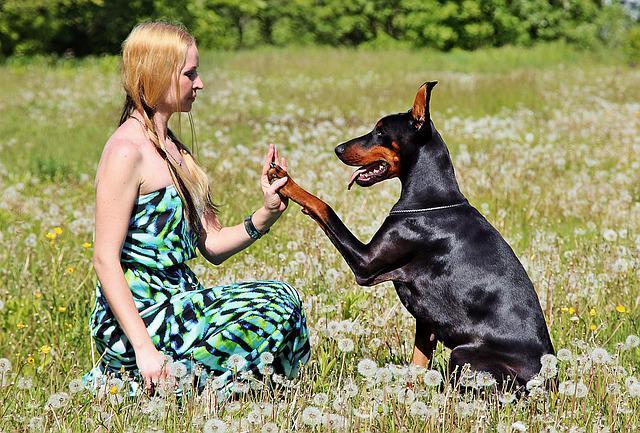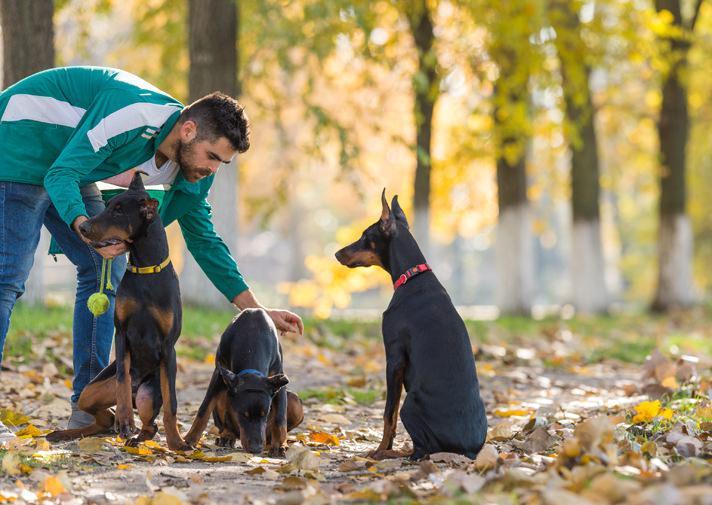The first image is the image on the left, the second image is the image on the right. Evaluate the accuracy of this statement regarding the images: "One image features a doberman with its front paws over the edge of a wooden fence.". Is it true? Answer yes or no. No. The first image is the image on the left, the second image is the image on the right. Evaluate the accuracy of this statement regarding the images: "One doberman has its front paws on a fence.". Is it true? Answer yes or no. No. 